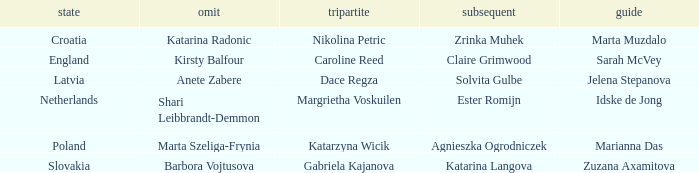Which skip has Zrinka Muhek as Second? Katarina Radonic. 